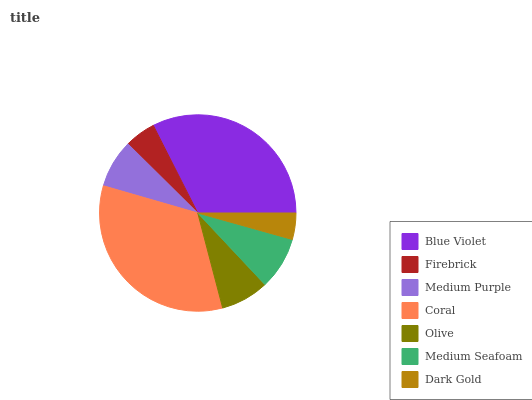Is Dark Gold the minimum?
Answer yes or no. Yes. Is Coral the maximum?
Answer yes or no. Yes. Is Firebrick the minimum?
Answer yes or no. No. Is Firebrick the maximum?
Answer yes or no. No. Is Blue Violet greater than Firebrick?
Answer yes or no. Yes. Is Firebrick less than Blue Violet?
Answer yes or no. Yes. Is Firebrick greater than Blue Violet?
Answer yes or no. No. Is Blue Violet less than Firebrick?
Answer yes or no. No. Is Medium Purple the high median?
Answer yes or no. Yes. Is Medium Purple the low median?
Answer yes or no. Yes. Is Firebrick the high median?
Answer yes or no. No. Is Dark Gold the low median?
Answer yes or no. No. 